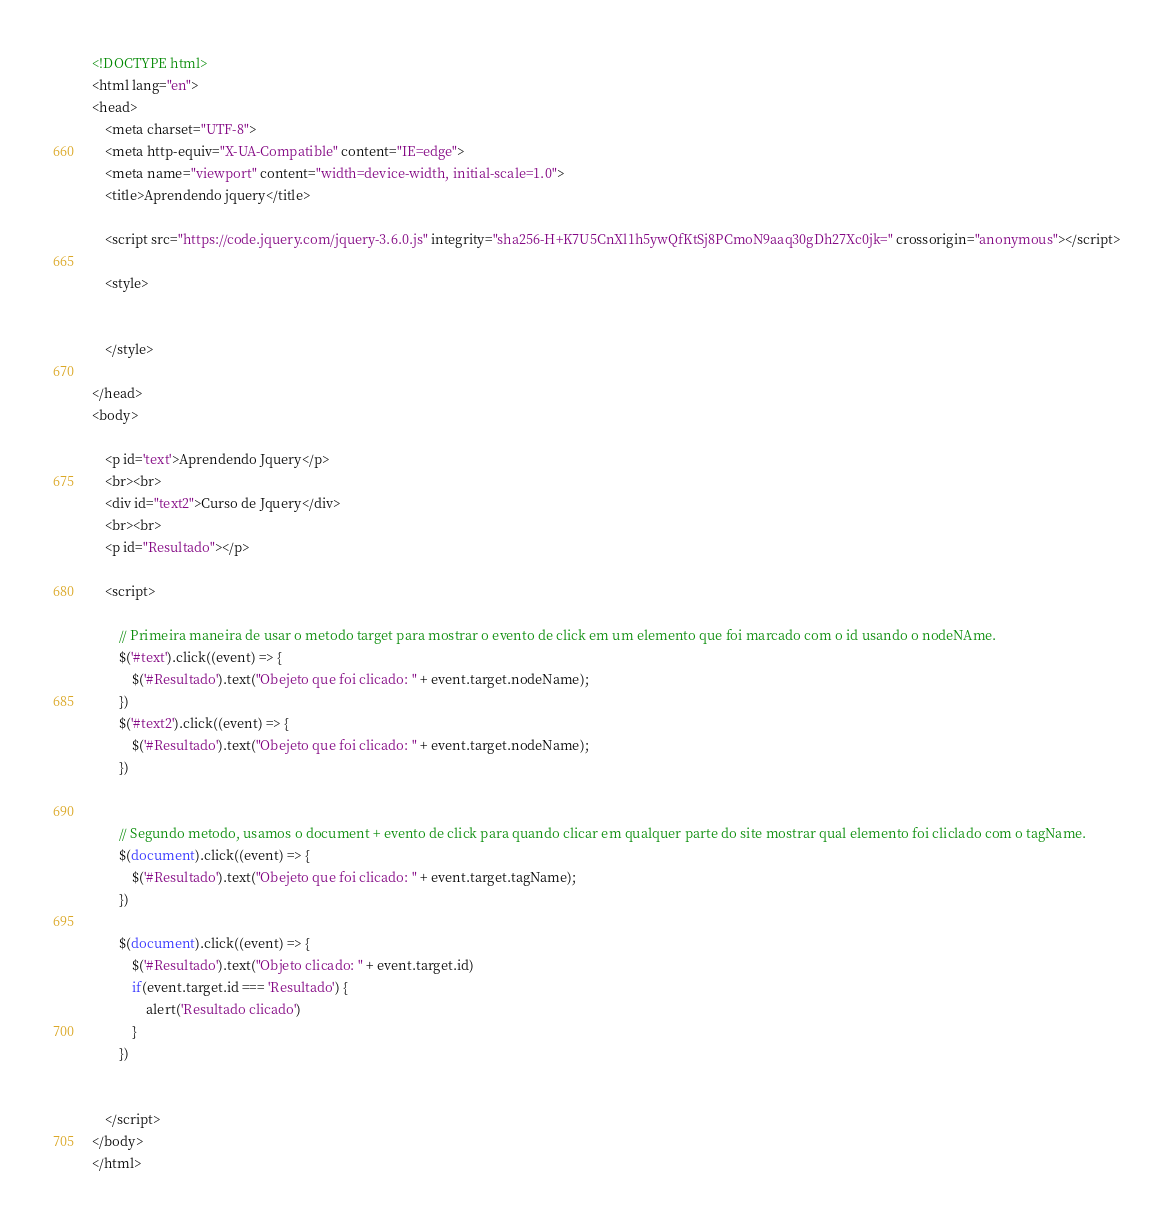<code> <loc_0><loc_0><loc_500><loc_500><_HTML_><!DOCTYPE html>
<html lang="en">
<head>
    <meta charset="UTF-8">
    <meta http-equiv="X-UA-Compatible" content="IE=edge">
    <meta name="viewport" content="width=device-width, initial-scale=1.0">
    <title>Aprendendo jquery</title>

    <script src="https://code.jquery.com/jquery-3.6.0.js" integrity="sha256-H+K7U5CnXl1h5ywQfKtSj8PCmoN9aaq30gDh27Xc0jk=" crossorigin="anonymous"></script>

    <style>


    </style>

</head>
<body>

    <p id='text'>Aprendendo Jquery</p>
    <br><br>
    <div id="text2">Curso de Jquery</div>
    <br><br>
    <p id="Resultado"></p>

    <script>

        // Primeira maneira de usar o metodo target para mostrar o evento de click em um elemento que foi marcado com o id usando o nodeNAme.
        $('#text').click((event) => {
            $('#Resultado').text("Obejeto que foi clicado: " + event.target.nodeName);
        })
        $('#text2').click((event) => {
            $('#Resultado').text("Obejeto que foi clicado: " + event.target.nodeName);
        })


        // Segundo metodo, usamos o document + evento de click para quando clicar em qualquer parte do site mostrar qual elemento foi cliclado com o tagName.
        $(document).click((event) => {
            $('#Resultado').text("Obejeto que foi clicado: " + event.target.tagName);
        })

        $(document).click((event) => {
            $('#Resultado').text("Objeto clicado: " + event.target.id)
            if(event.target.id === 'Resultado') {
                alert('Resultado clicado')
            }
        })


    </script>
</body>
</html></code> 